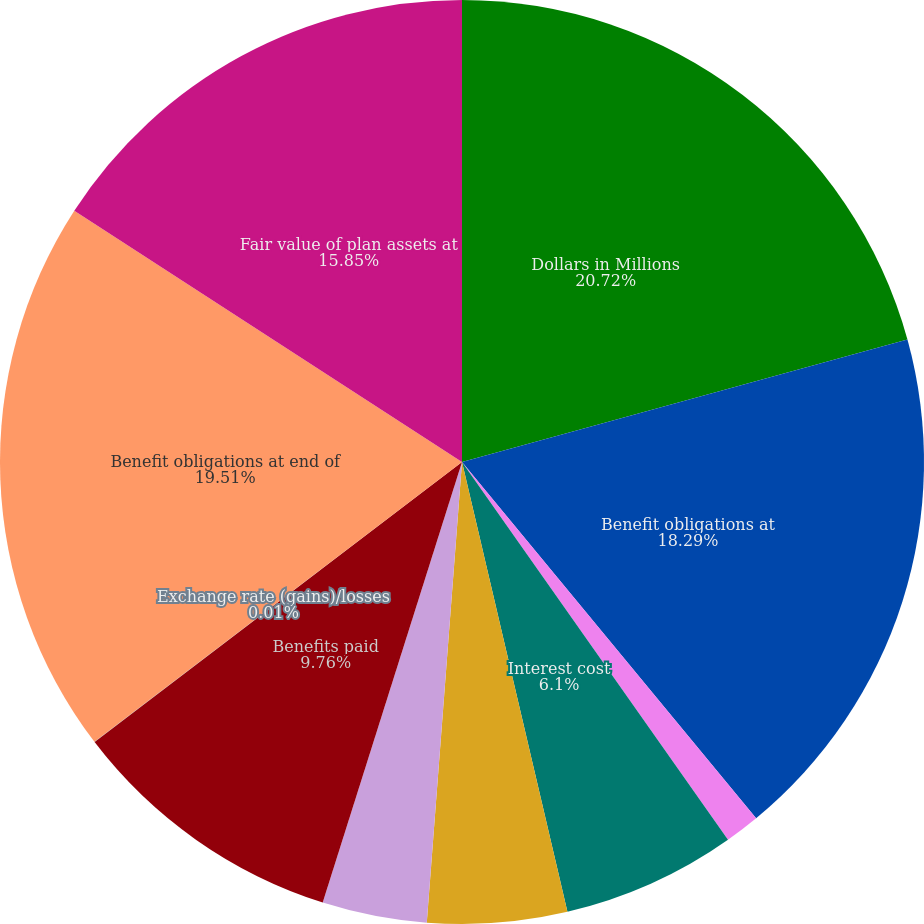Convert chart to OTSL. <chart><loc_0><loc_0><loc_500><loc_500><pie_chart><fcel>Dollars in Millions<fcel>Benefit obligations at<fcel>Service cost-benefits earned<fcel>Interest cost<fcel>Plan participants'<fcel>Actuarial losses/(gains)<fcel>Benefits paid<fcel>Exchange rate (gains)/losses<fcel>Benefit obligations at end of<fcel>Fair value of plan assets at<nl><fcel>20.73%<fcel>18.29%<fcel>1.22%<fcel>6.1%<fcel>4.88%<fcel>3.66%<fcel>9.76%<fcel>0.01%<fcel>19.51%<fcel>15.85%<nl></chart> 